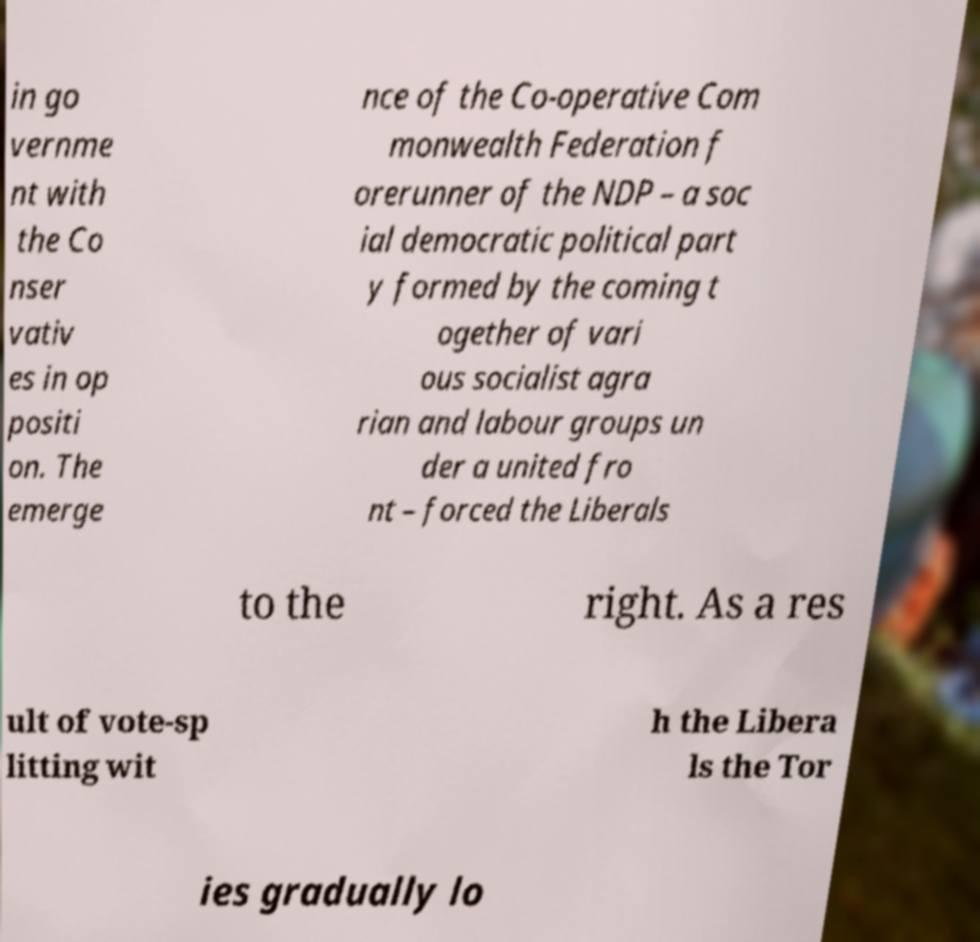Can you accurately transcribe the text from the provided image for me? in go vernme nt with the Co nser vativ es in op positi on. The emerge nce of the Co-operative Com monwealth Federation f orerunner of the NDP – a soc ial democratic political part y formed by the coming t ogether of vari ous socialist agra rian and labour groups un der a united fro nt – forced the Liberals to the right. As a res ult of vote-sp litting wit h the Libera ls the Tor ies gradually lo 